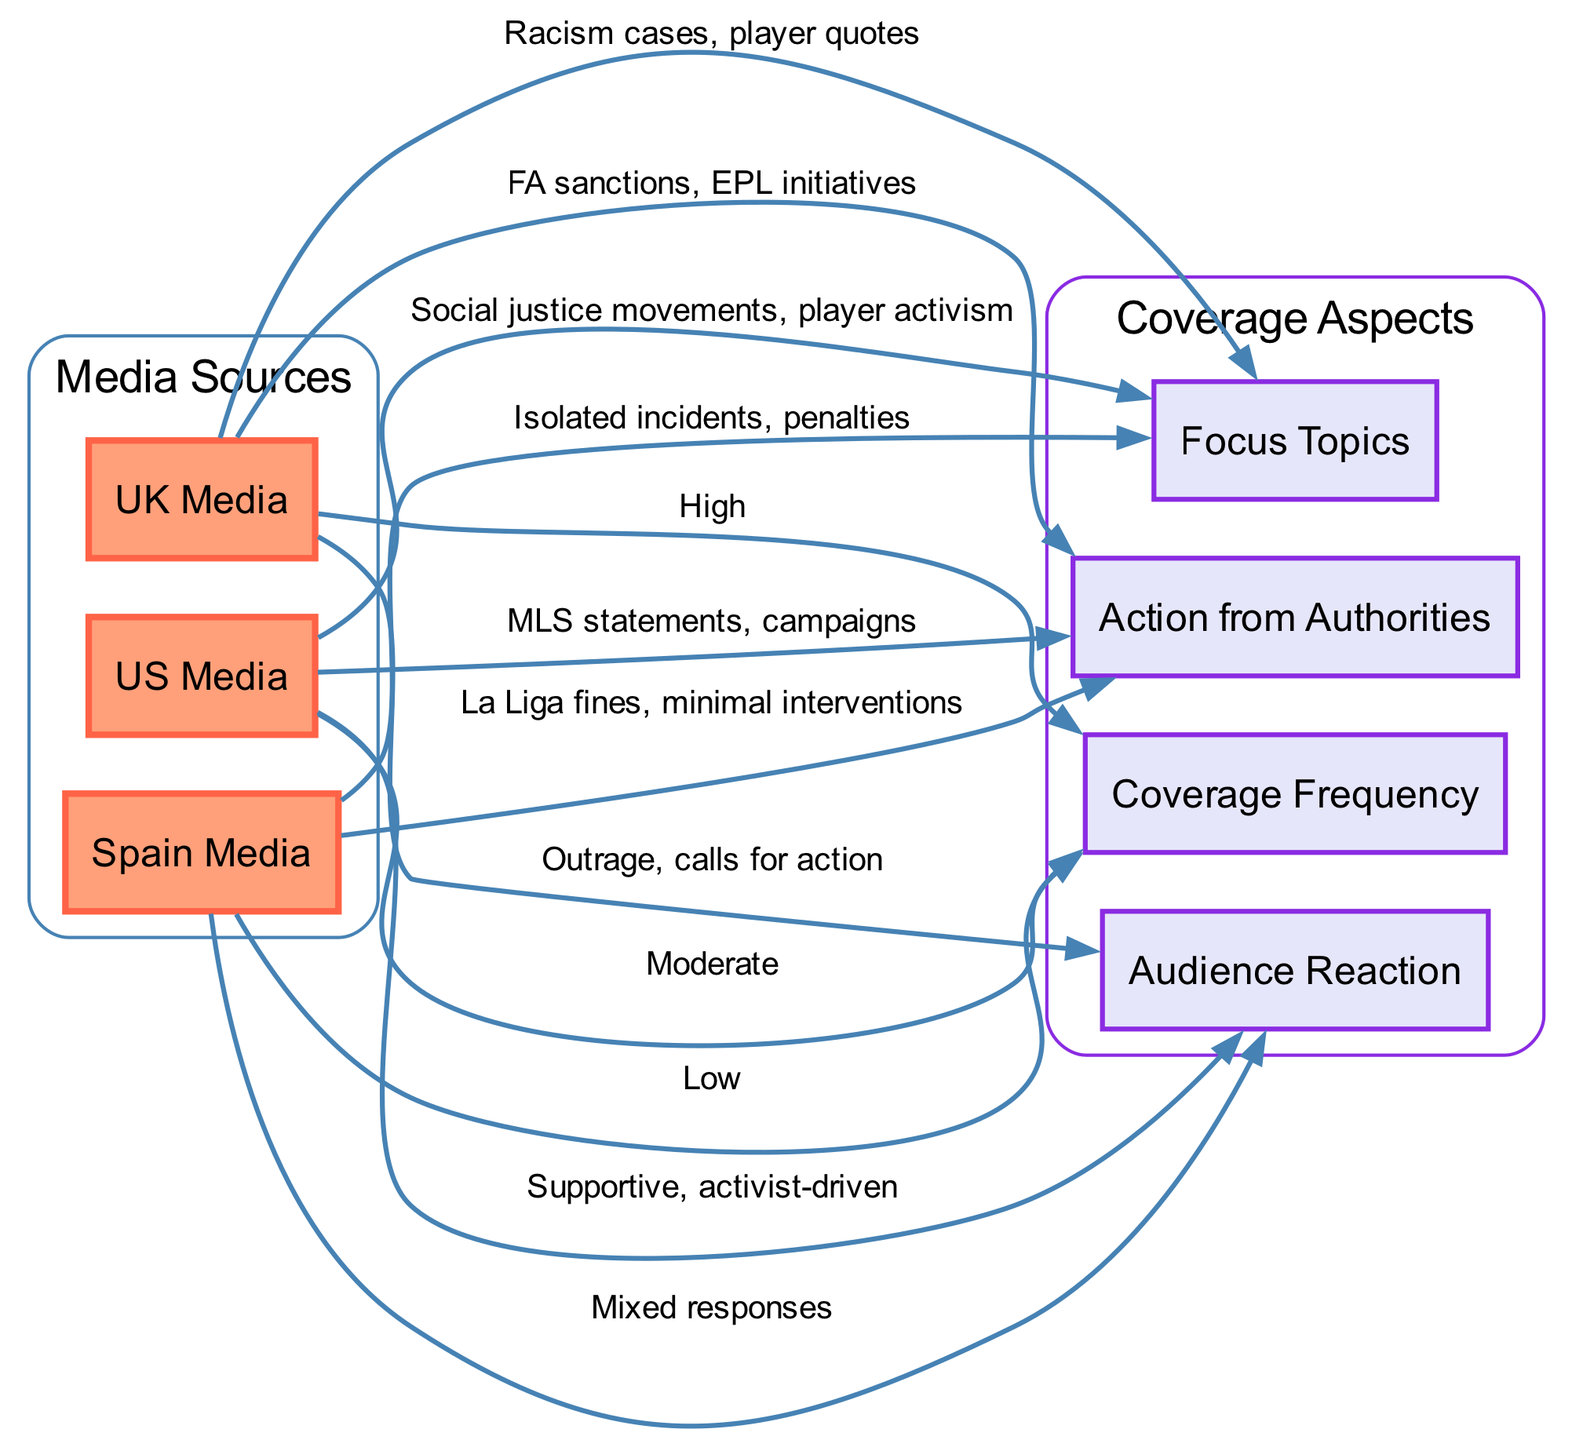What is the coverage frequency for UK Media? The diagram shows that the edge from "UK Media" to "Coverage Frequency" is labeled "High." This indicates that UK Media has a high frequency of coverage concerning racial issues in football.
Answer: High Which country has the lowest focus topics coverage? By examining the edges, the edge from "Spain Media" to "Focus Topics" is labeled "Isolated incidents, penalties," while the other media sources (UK and US) refer to more substantial topics. This indicates that Spain Media has lower focus topics coverage.
Answer: Spain Media What type of audience reaction is primarily associated with US Media? The edge connecting "US Media" and "Audience Reaction" is labeled "Supportive, activist-driven." This means that the primary type of audience reaction linked to US Media's coverage is supportive and aligned with activism.
Answer: Supportive, activist-driven How many media sources are represented in the diagram? The diagram illustrates three media sources: UK Media, US Media, and Spain Media. By counting these nodes, we reach the total number represented.
Answer: 3 What actions from authorities are highlighted in the UK Media coverage? The edge from "UK Media" to "Action from Authorities" is labeled "FA sanctions, EPL initiatives." This specifically details the actions taken by authorities in response to racial issues in football in the UK.
Answer: FA sanctions, EPL initiatives What is the audience reaction for Spain Media? The edge from "Spain Media" to "Audience Reaction" states "Mixed responses." This suggests that the audience reaction to Spain Media's coverage is varied.
Answer: Mixed responses Which country’s media has a focus on social justice movements? The diagram indicates that "US Media" connects to "Focus Topics" with the label "Social justice movements, player activism." This shows that the US Media particularly emphasizes social justice topics.
Answer: US Media What type of actions from authorities are associated with Spain Media? The edge between "Spain Media" and "Action from Authorities" is labeled "La Liga fines, minimal interventions." This reveals that the actions taken by authorities in Spain are relatively mild compared to other countries.
Answer: La Liga fines, minimal interventions What is the coverage frequency for Spain Media? The relationship between "Spain Media" and "Coverage Frequency" is represented as "Low." This indicates that Spain Media's coverage regarding racial issues in football is less frequent compared to other media sources.
Answer: Low 